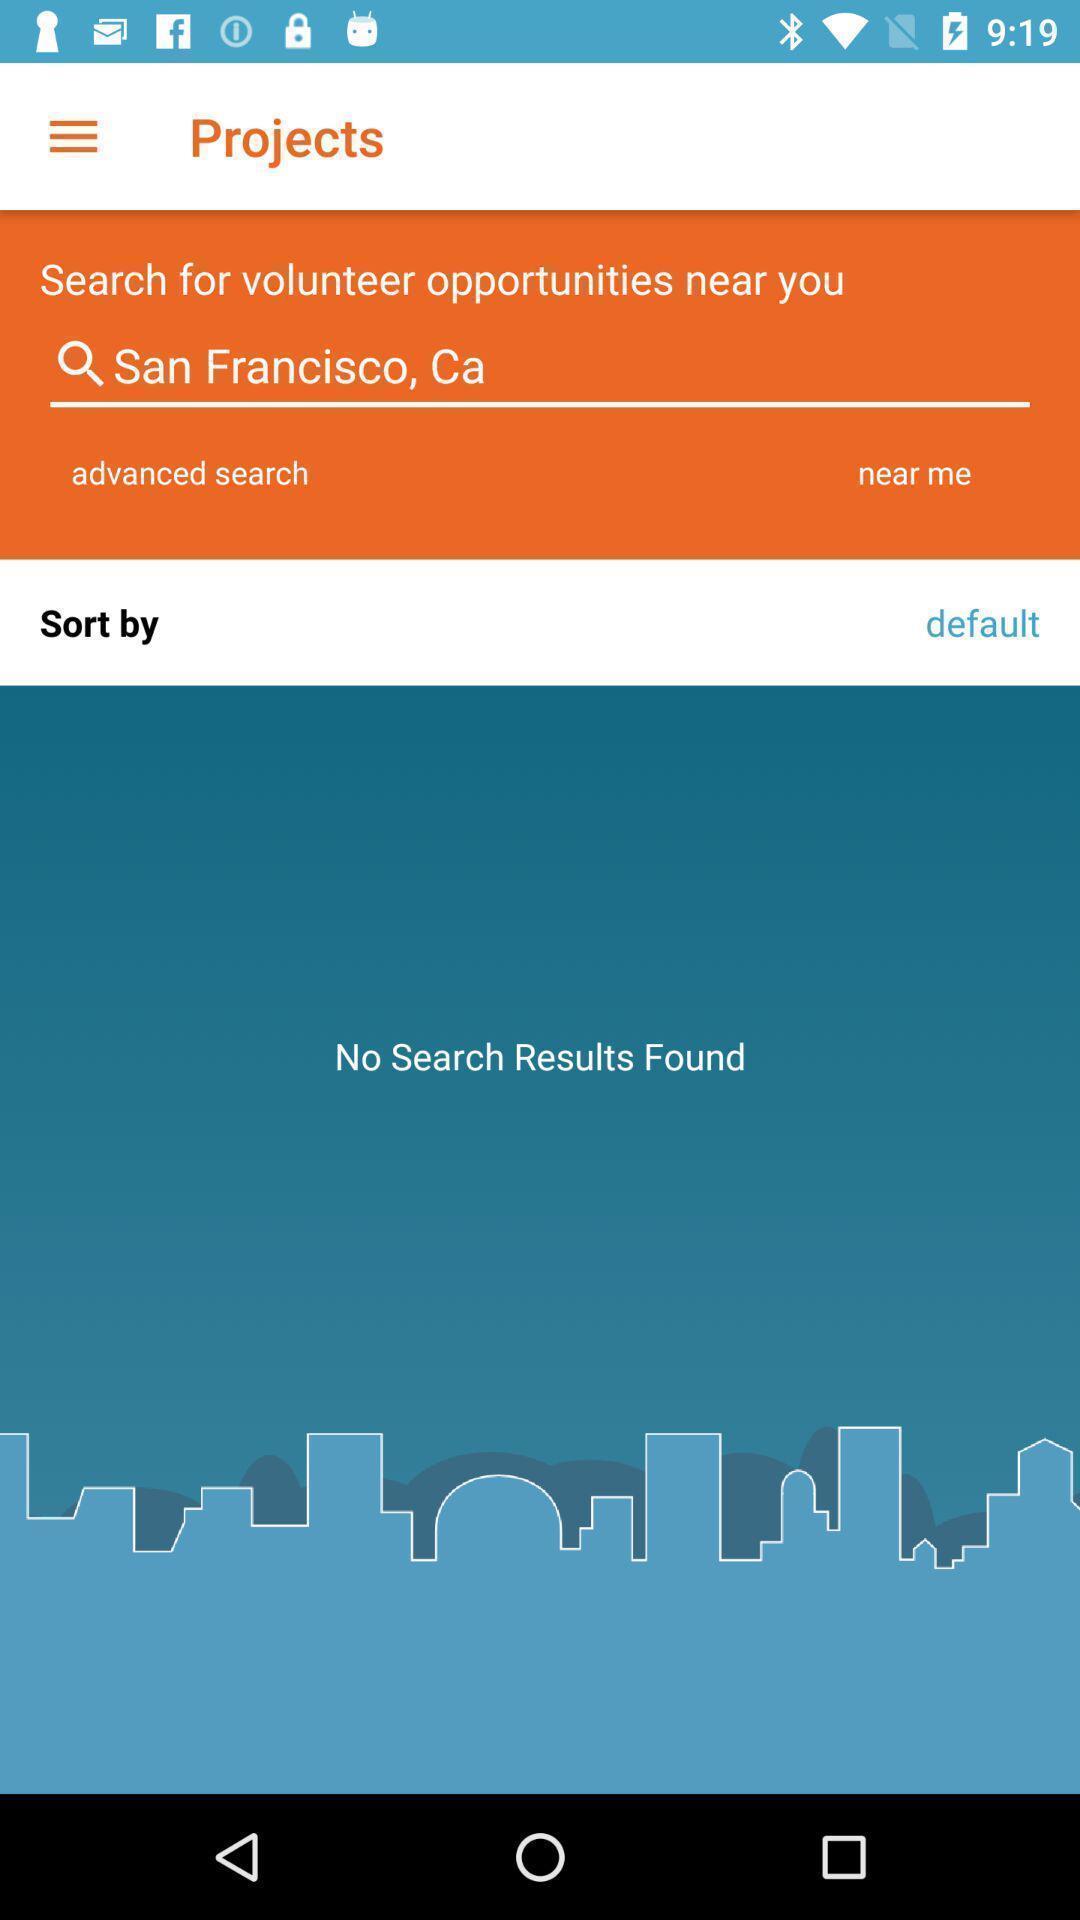Describe the key features of this screenshot. Search bar to find jobs based on location. 